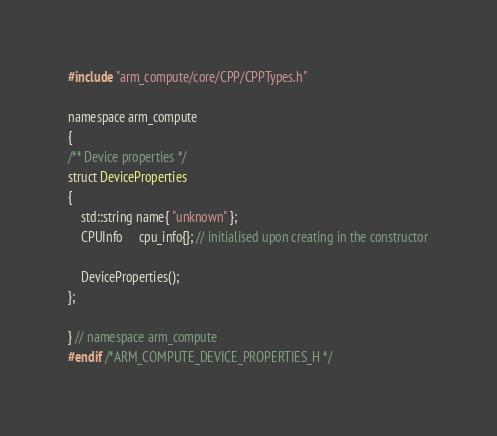Convert code to text. <code><loc_0><loc_0><loc_500><loc_500><_C_>
#include "arm_compute/core/CPP/CPPTypes.h"

namespace arm_compute
{
/** Device properties */
struct DeviceProperties
{
    std::string name{ "unknown" };
    CPUInfo     cpu_info{}; // initialised upon creating in the constructor

    DeviceProperties();
};

} // namespace arm_compute
#endif /*ARM_COMPUTE_DEVICE_PROPERTIES_H */
</code> 